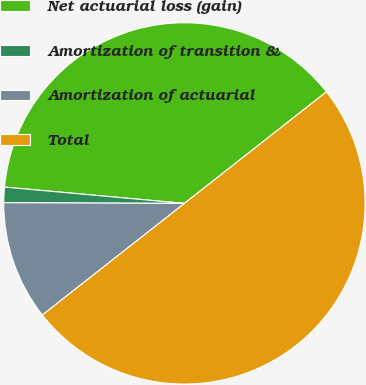Convert chart to OTSL. <chart><loc_0><loc_0><loc_500><loc_500><pie_chart><fcel>Net actuarial loss (gain)<fcel>Amortization of transition &<fcel>Amortization of actuarial<fcel>Total<nl><fcel>37.96%<fcel>1.38%<fcel>10.66%<fcel>50.0%<nl></chart> 